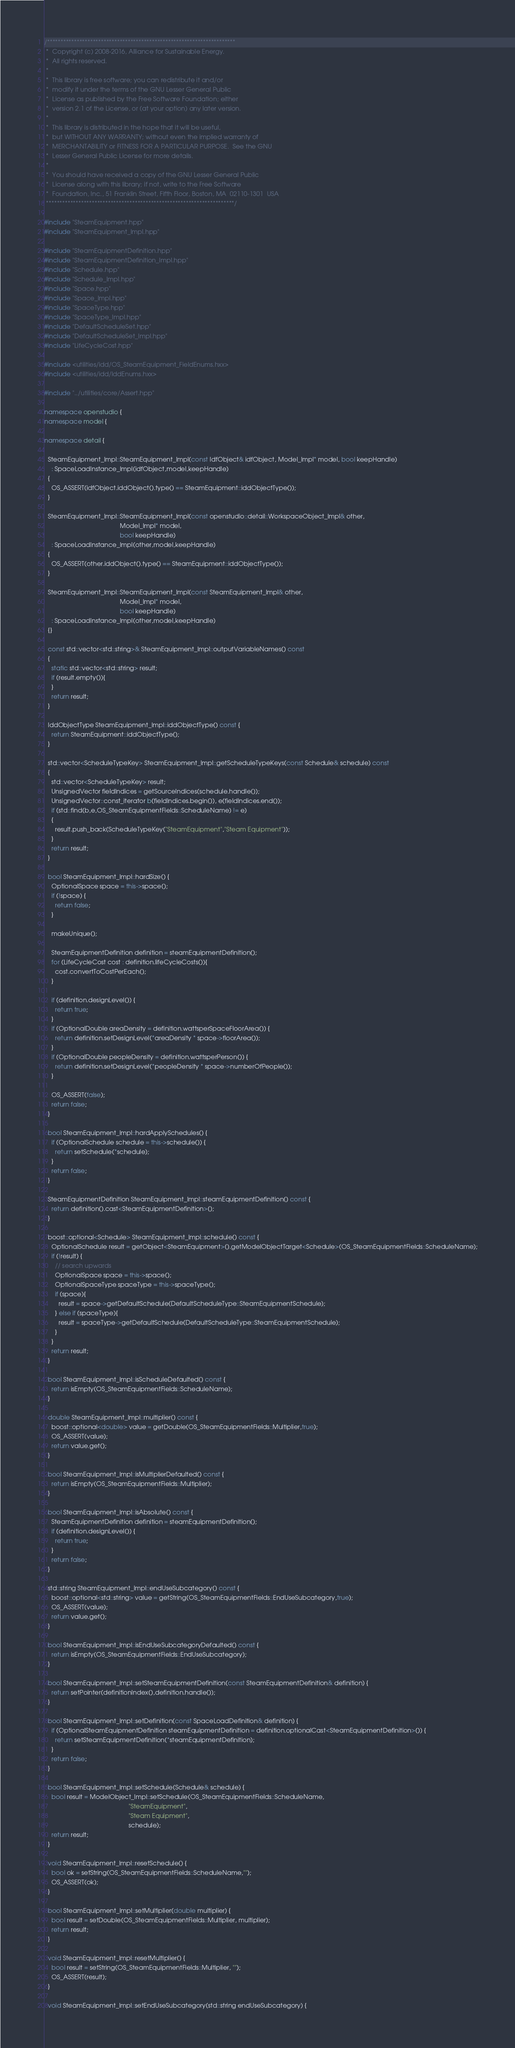<code> <loc_0><loc_0><loc_500><loc_500><_C++_>/**********************************************************************
 *  Copyright (c) 2008-2016, Alliance for Sustainable Energy.
 *  All rights reserved.
 *
 *  This library is free software; you can redistribute it and/or
 *  modify it under the terms of the GNU Lesser General Public
 *  License as published by the Free Software Foundation; either
 *  version 2.1 of the License, or (at your option) any later version.
 *
 *  This library is distributed in the hope that it will be useful,
 *  but WITHOUT ANY WARRANTY; without even the implied warranty of
 *  MERCHANTABILITY or FITNESS FOR A PARTICULAR PURPOSE.  See the GNU
 *  Lesser General Public License for more details.
 *
 *  You should have received a copy of the GNU Lesser General Public
 *  License along with this library; if not, write to the Free Software
 *  Foundation, Inc., 51 Franklin Street, Fifth Floor, Boston, MA  02110-1301  USA
 **********************************************************************/

#include "SteamEquipment.hpp"
#include "SteamEquipment_Impl.hpp"

#include "SteamEquipmentDefinition.hpp"
#include "SteamEquipmentDefinition_Impl.hpp"
#include "Schedule.hpp"
#include "Schedule_Impl.hpp"
#include "Space.hpp"
#include "Space_Impl.hpp"
#include "SpaceType.hpp"
#include "SpaceType_Impl.hpp"
#include "DefaultScheduleSet.hpp"
#include "DefaultScheduleSet_Impl.hpp"
#include "LifeCycleCost.hpp"

#include <utilities/idd/OS_SteamEquipment_FieldEnums.hxx>
#include <utilities/idd/IddEnums.hxx>

#include "../utilities/core/Assert.hpp"

namespace openstudio {
namespace model {

namespace detail {

  SteamEquipment_Impl::SteamEquipment_Impl(const IdfObject& idfObject, Model_Impl* model, bool keepHandle)
    : SpaceLoadInstance_Impl(idfObject,model,keepHandle)
  {
    OS_ASSERT(idfObject.iddObject().type() == SteamEquipment::iddObjectType());
  }

  SteamEquipment_Impl::SteamEquipment_Impl(const openstudio::detail::WorkspaceObject_Impl& other,
                                           Model_Impl* model,
                                           bool keepHandle)
    : SpaceLoadInstance_Impl(other,model,keepHandle)
  {
    OS_ASSERT(other.iddObject().type() == SteamEquipment::iddObjectType());
  }

  SteamEquipment_Impl::SteamEquipment_Impl(const SteamEquipment_Impl& other,
                                           Model_Impl* model,
                                           bool keepHandle)
    : SpaceLoadInstance_Impl(other,model,keepHandle)
  {}

  const std::vector<std::string>& SteamEquipment_Impl::outputVariableNames() const
  {
    static std::vector<std::string> result;
    if (result.empty()){
    }
    return result;
  }

  IddObjectType SteamEquipment_Impl::iddObjectType() const {
    return SteamEquipment::iddObjectType();
  }

  std::vector<ScheduleTypeKey> SteamEquipment_Impl::getScheduleTypeKeys(const Schedule& schedule) const
  {
    std::vector<ScheduleTypeKey> result;
    UnsignedVector fieldIndices = getSourceIndices(schedule.handle());
    UnsignedVector::const_iterator b(fieldIndices.begin()), e(fieldIndices.end());
    if (std::find(b,e,OS_SteamEquipmentFields::ScheduleName) != e)
    {
      result.push_back(ScheduleTypeKey("SteamEquipment","Steam Equipment"));
    }
    return result;
  }

  bool SteamEquipment_Impl::hardSize() {
    OptionalSpace space = this->space();
    if (!space) {
      return false;
    }

    makeUnique();

    SteamEquipmentDefinition definition = steamEquipmentDefinition();
    for (LifeCycleCost cost : definition.lifeCycleCosts()){
      cost.convertToCostPerEach();
    }

    if (definition.designLevel()) {
      return true;
    }
    if (OptionalDouble areaDensity = definition.wattsperSpaceFloorArea()) {
      return definition.setDesignLevel(*areaDensity * space->floorArea());
    }
    if (OptionalDouble peopleDensity = definition.wattsperPerson()) {
      return definition.setDesignLevel(*peopleDensity * space->numberOfPeople());
    }

    OS_ASSERT(false);
    return false;
  }

  bool SteamEquipment_Impl::hardApplySchedules() {
    if (OptionalSchedule schedule = this->schedule()) {
      return setSchedule(*schedule);
    }
    return false;
  }

  SteamEquipmentDefinition SteamEquipment_Impl::steamEquipmentDefinition() const {
    return definition().cast<SteamEquipmentDefinition>();
  }

  boost::optional<Schedule> SteamEquipment_Impl::schedule() const {
    OptionalSchedule result = getObject<SteamEquipment>().getModelObjectTarget<Schedule>(OS_SteamEquipmentFields::ScheduleName);
    if (!result) {
      // search upwards
      OptionalSpace space = this->space();
      OptionalSpaceType spaceType = this->spaceType();
      if (space){
        result = space->getDefaultSchedule(DefaultScheduleType::SteamEquipmentSchedule);
      } else if (spaceType){
        result = spaceType->getDefaultSchedule(DefaultScheduleType::SteamEquipmentSchedule);
      }
    }
    return result;
  }

  bool SteamEquipment_Impl::isScheduleDefaulted() const {
    return isEmpty(OS_SteamEquipmentFields::ScheduleName);
  }

  double SteamEquipment_Impl::multiplier() const {
    boost::optional<double> value = getDouble(OS_SteamEquipmentFields::Multiplier,true);
    OS_ASSERT(value);
    return value.get();
  }

  bool SteamEquipment_Impl::isMultiplierDefaulted() const {
    return isEmpty(OS_SteamEquipmentFields::Multiplier);
  }

  bool SteamEquipment_Impl::isAbsolute() const {
    SteamEquipmentDefinition definition = steamEquipmentDefinition();
    if (definition.designLevel()) {
      return true;
    }
    return false;
  }

  std::string SteamEquipment_Impl::endUseSubcategory() const {
    boost::optional<std::string> value = getString(OS_SteamEquipmentFields::EndUseSubcategory,true);
    OS_ASSERT(value);
    return value.get();
  }

  bool SteamEquipment_Impl::isEndUseSubcategoryDefaulted() const {
    return isEmpty(OS_SteamEquipmentFields::EndUseSubcategory);
  }

  bool SteamEquipment_Impl::setSteamEquipmentDefinition(const SteamEquipmentDefinition& definition) {
    return setPointer(definitionIndex(),definition.handle());
  }

  bool SteamEquipment_Impl::setDefinition(const SpaceLoadDefinition& definition) {
    if (OptionalSteamEquipmentDefinition steamEquipmentDefinition = definition.optionalCast<SteamEquipmentDefinition>()) {
      return setSteamEquipmentDefinition(*steamEquipmentDefinition);
    }
    return false;
  }

  bool SteamEquipment_Impl::setSchedule(Schedule& schedule) {
    bool result = ModelObject_Impl::setSchedule(OS_SteamEquipmentFields::ScheduleName,
                                                "SteamEquipment",
                                                "Steam Equipment",
                                                schedule);
    return result;
  }

  void SteamEquipment_Impl::resetSchedule() {
    bool ok = setString(OS_SteamEquipmentFields::ScheduleName,"");
    OS_ASSERT(ok);
  }

  bool SteamEquipment_Impl::setMultiplier(double multiplier) {
    bool result = setDouble(OS_SteamEquipmentFields::Multiplier, multiplier);
    return result;
  }

  void SteamEquipment_Impl::resetMultiplier() {
    bool result = setString(OS_SteamEquipmentFields::Multiplier, "");
    OS_ASSERT(result);
  }

  void SteamEquipment_Impl::setEndUseSubcategory(std::string endUseSubcategory) {</code> 